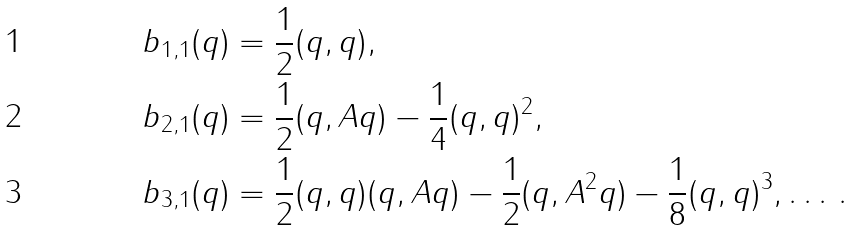<formula> <loc_0><loc_0><loc_500><loc_500>& b _ { 1 , 1 } ( q ) = \frac { 1 } { 2 } ( q , q ) , \\ & b _ { 2 , 1 } ( q ) = \frac { 1 } { 2 } ( q , A q ) - \frac { 1 } { 4 } ( q , q ) ^ { 2 } , \\ & b _ { 3 , 1 } ( q ) = \frac { 1 } { 2 } ( q , q ) ( q , A q ) - \frac { 1 } { 2 } ( q , A ^ { 2 } q ) - \frac { 1 } { 8 } ( q , q ) ^ { 3 } , \dots \, .</formula> 